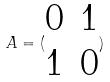Convert formula to latex. <formula><loc_0><loc_0><loc_500><loc_500>A = ( \begin{matrix} 0 & 1 \\ 1 & 0 \end{matrix} )</formula> 